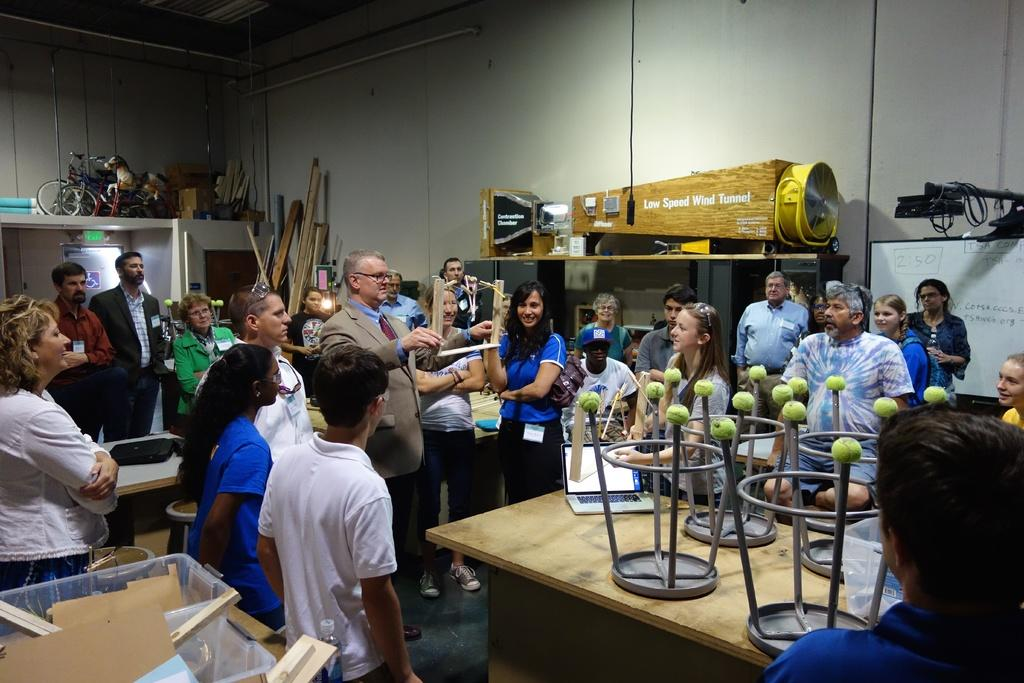How many people can be seen in the image? There are many people standing in the image. What type of furniture is present in the image? There is a table in the image. Is there any additional seating on the table? Yes, a stool is present on the table. What type of location is depicted in the image? The image depicts a room. Can you see a nest in the image? No, there is no nest present in the image. Is the room filled with quicksand? No, there is no quicksand present in the image; it depicts a room with people, a table, and a stool. 